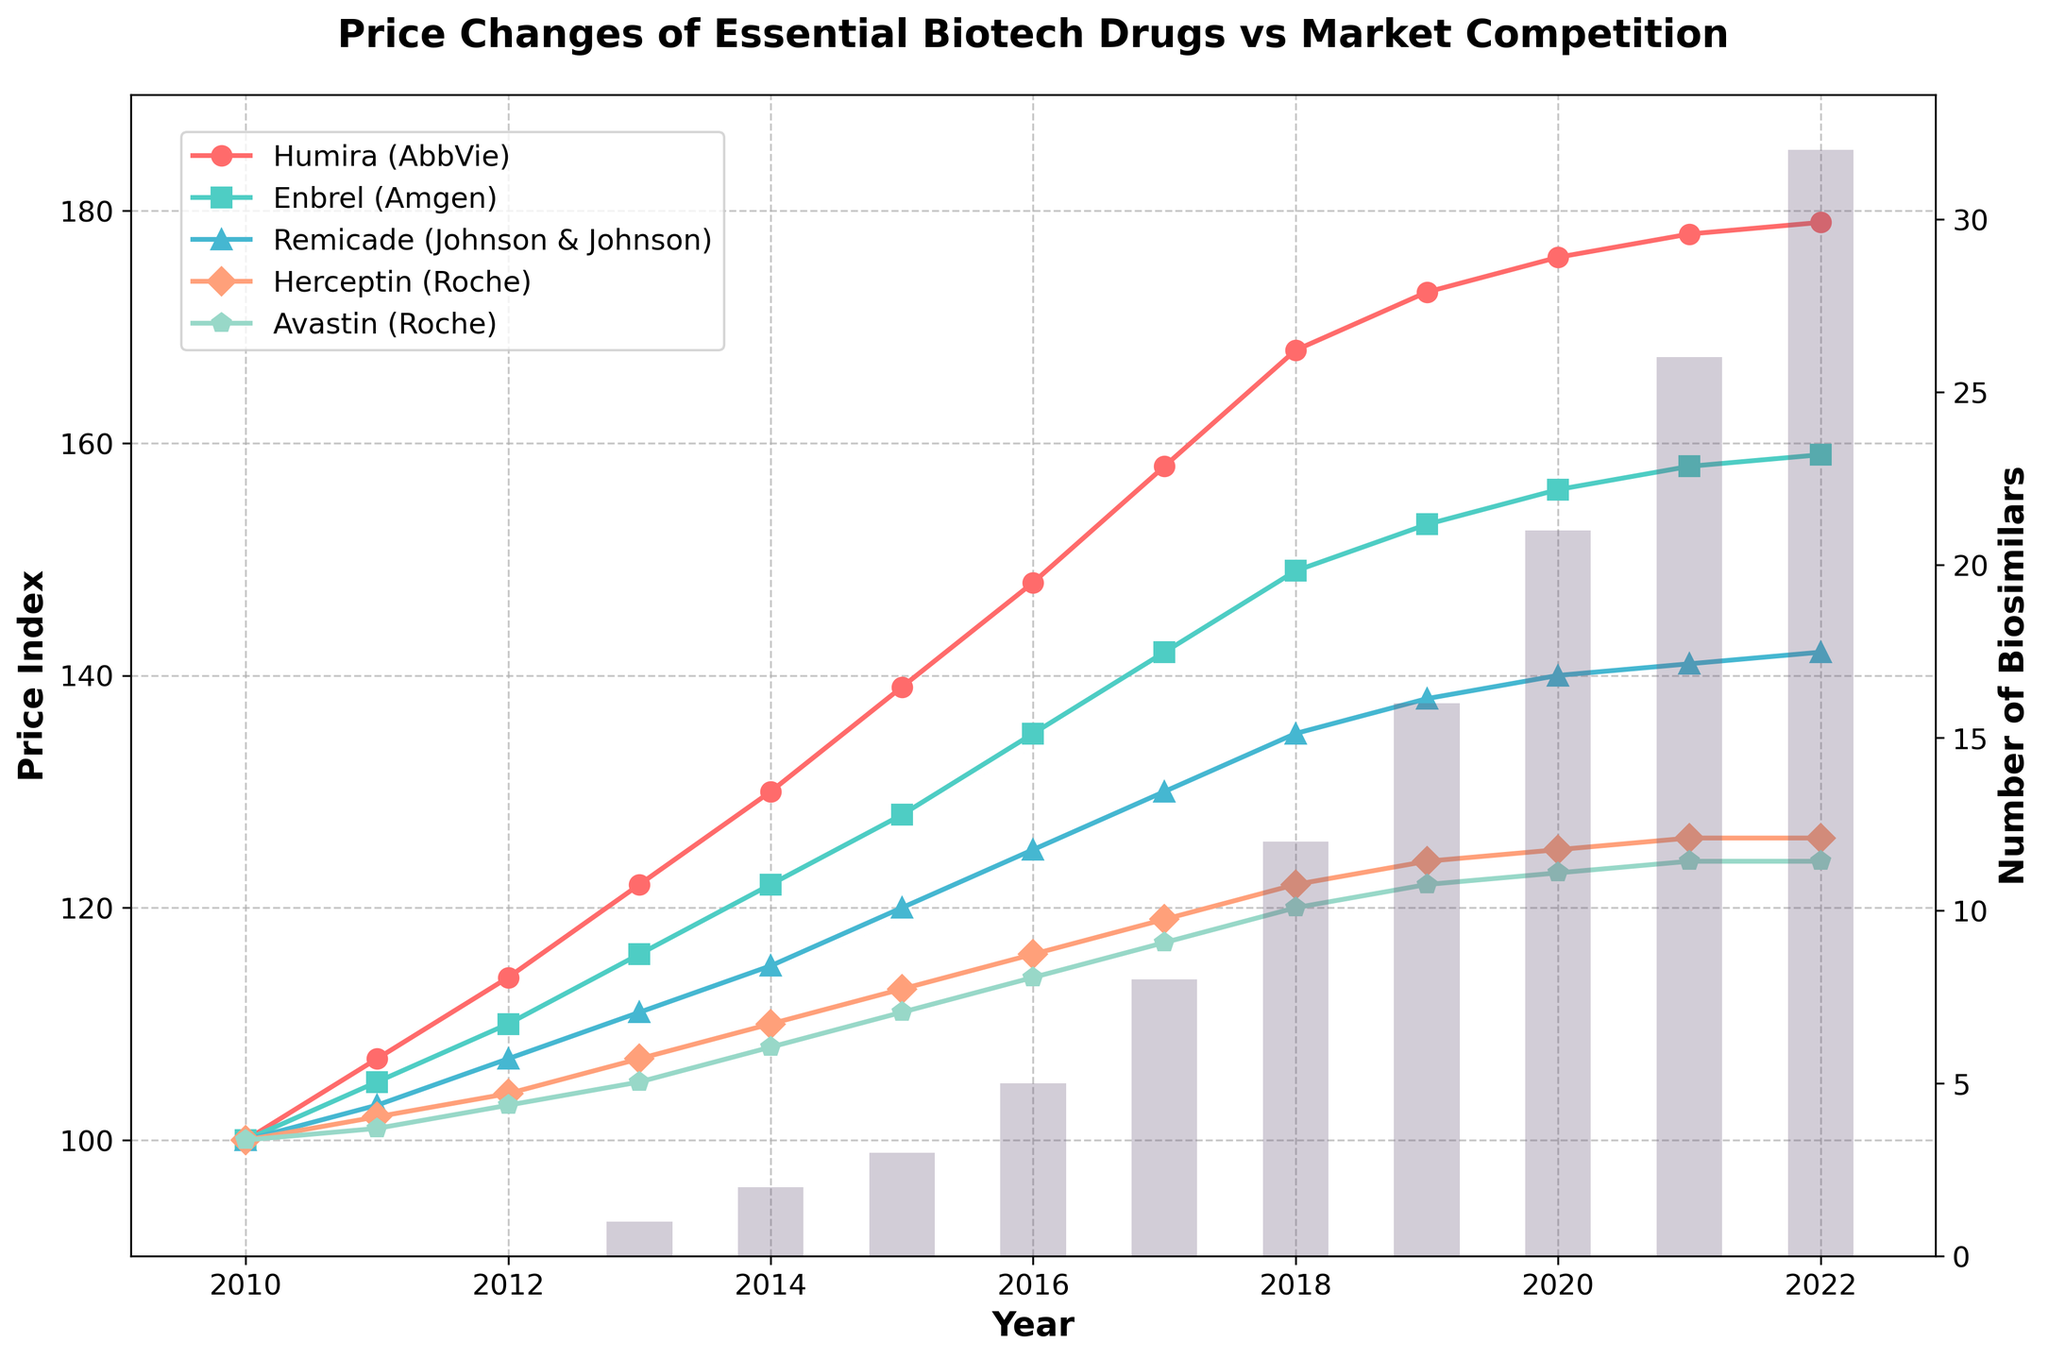By how much did the price index of Humira increase from 2010 to 2022? To find the increase, subtract the price index of 2010 from the price index of 2022. The price index of Humira in 2022 is 179, and in 2010 it was 100. So, 179 - 100 = 79.
Answer: 79 Which drug showed the smallest increase in price index between 2010 and 2022, and what was the increase? Calculate the increase for each drug by subtracting the price index of 2010 from the price index of 2022. The increases are as follows: Humira (79), Enbrel (59), Remicade (42), Herceptin (26), and Avastin (24). The smallest increase is for Avastin, which is 24.
Answer: Avastin, 24 How many more biosimilars were there in 2022 compared to 2013? Subtract the number of biosimilars in 2013 from the number in 2022. There were 32 biosimilars in 2022 and 1 in 2013. So, 32 - 1 = 31.
Answer: 31 During which year did the price index of Enbrel cross 150? Identify the year by checking the values for Enbrel over time. In 2018, the price index is 149 and in 2019 it is 153. Therefore, it crossed 150 between 2018 and 2019.
Answer: 2019 What is the average price index of Herceptin over the period 2010-2022? Calculate the average by summing up the price index values of Herceptin for each year and dividing by the number of years (13). The sum is 100+102+104+107+110+113+116+119+122+124+125+126+126 = 1394. The average is 1394 / 13 = 107.23.
Answer: 107.23 From 2017 to 2022, which drug had the highest rate of price increase, and what was the value? To find the highest rate of increase, calculate the rate for each drug by subtracting the price index in 2017 from the price index in 2022 and dividing by the years (5). The increases are: Humira (179-158)/5=4.2, Enbrel (159-142)/5=3.4, Remicade (142-130)/5=2.4, Herceptin (126-119)/5=1.4, and Avastin (124-117)/5=1.4. Humira had the highest rate of increase, which is 4.2 per year.
Answer: Humira, 4.2 How does the trend in the number of biosimilars appear over the years? Observe the bars representing the number of biosimilars from 2010 to 2022. There is a continuous upward trend, with a gradual increase initially and a steeper rise from 2017 onwards.
Answer: Increasing trend Which year saw the largest single-year increase in the number of biosimilars? Find the year with the largest difference in the number of biosimilars by comparing consecutive years. The increase from 2017 to 2018 was the largest, with an increase from 8 to 12 biosimilars, which is 4.
Answer: 2018 Compare the price indexes of Remicade and Enbrel in 2022. Which one is higher and by how much? Look at the price indexes for 2022. Remicade's price index is 142, and Enbrel's is 159. Subtract Remicade's price index from Enbrel's: 159 - 142 = 17. Enbrel's index is higher by 17.
Answer: Enbrel, by 17 